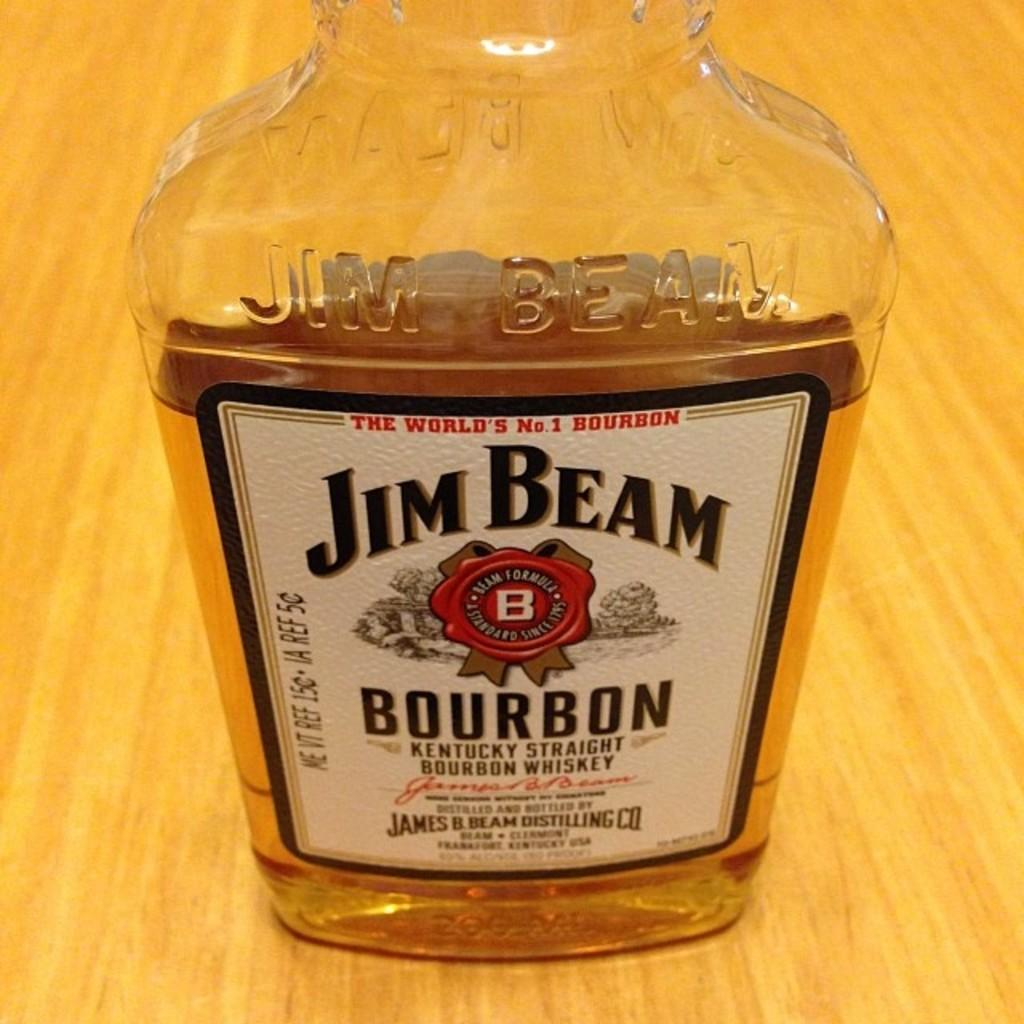<image>
Share a concise interpretation of the image provided. A bottle of Jim Beam bourbon whiskey sitting on a wooden table. 